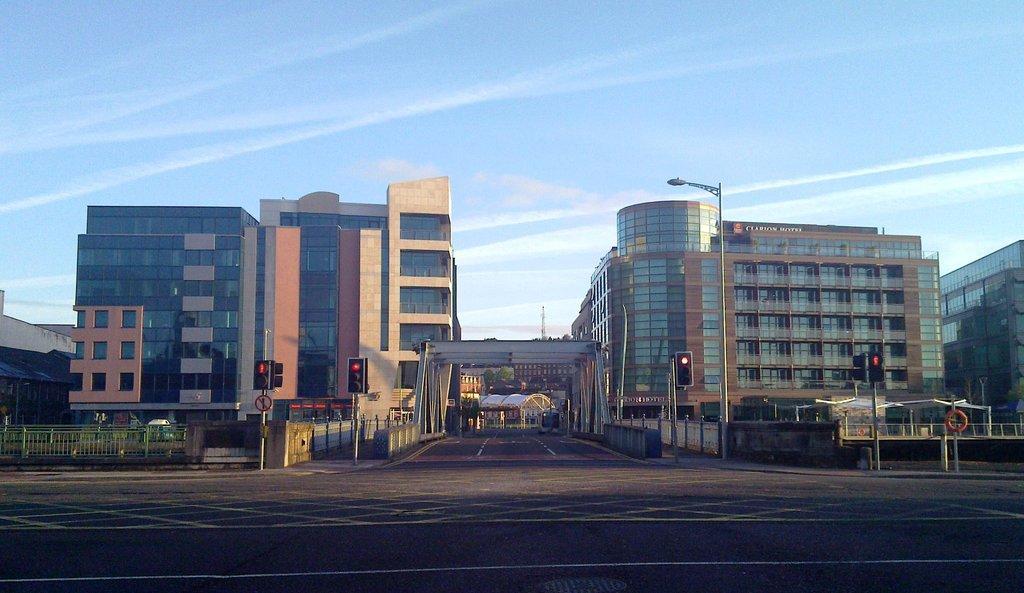How would you summarize this image in a sentence or two? In this image, we can see buildings, trees, poles, traffic lights, railings and at the bottom, there is road. At the top, there is sky. 